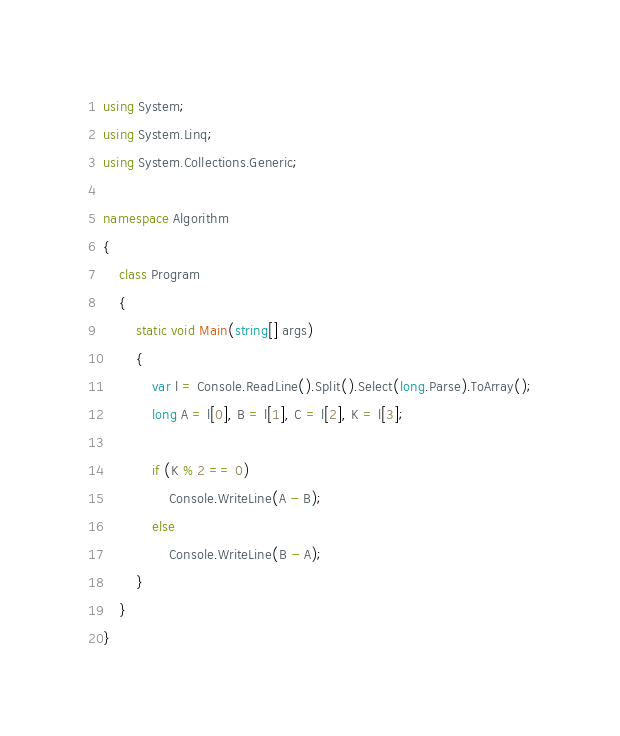<code> <loc_0><loc_0><loc_500><loc_500><_C#_>using System;
using System.Linq;
using System.Collections.Generic;

namespace Algorithm
{
    class Program
    {
        static void Main(string[] args)
        {
            var l = Console.ReadLine().Split().Select(long.Parse).ToArray();
            long A = l[0], B = l[1], C = l[2], K = l[3];

            if (K % 2 == 0)
                Console.WriteLine(A - B);
            else
                Console.WriteLine(B - A);
        }
    }
}
</code> 